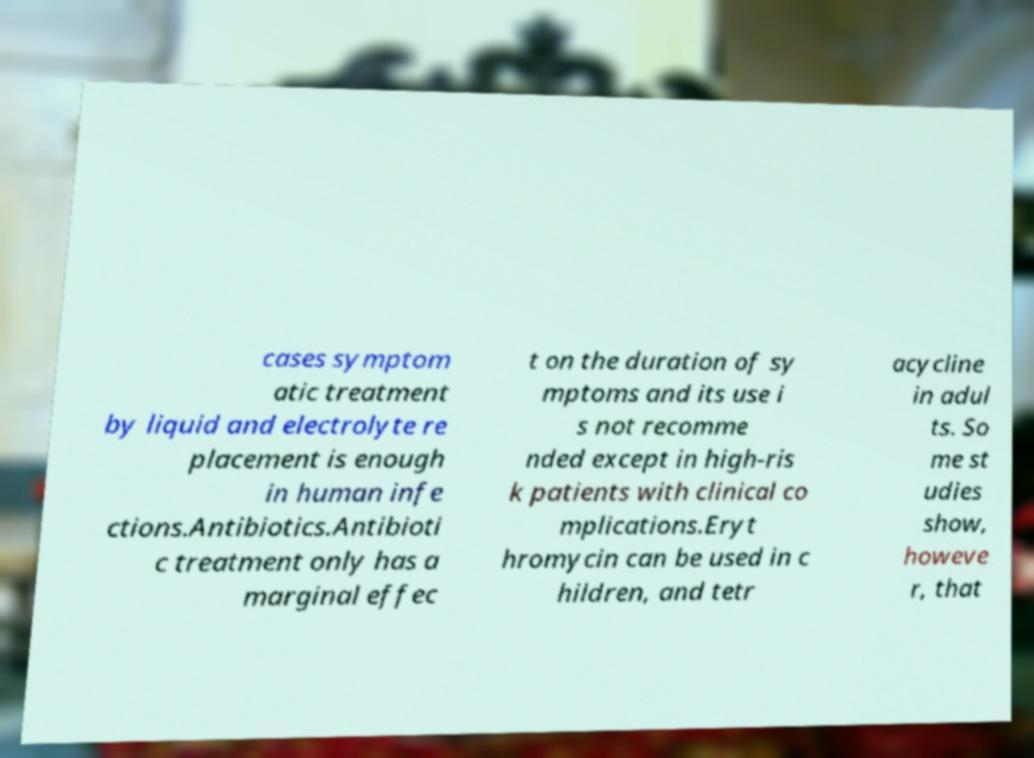Could you assist in decoding the text presented in this image and type it out clearly? cases symptom atic treatment by liquid and electrolyte re placement is enough in human infe ctions.Antibiotics.Antibioti c treatment only has a marginal effec t on the duration of sy mptoms and its use i s not recomme nded except in high-ris k patients with clinical co mplications.Eryt hromycin can be used in c hildren, and tetr acycline in adul ts. So me st udies show, howeve r, that 